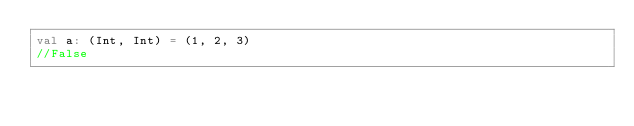<code> <loc_0><loc_0><loc_500><loc_500><_Scala_>val a: (Int, Int) = (1, 2, 3)
//False</code> 